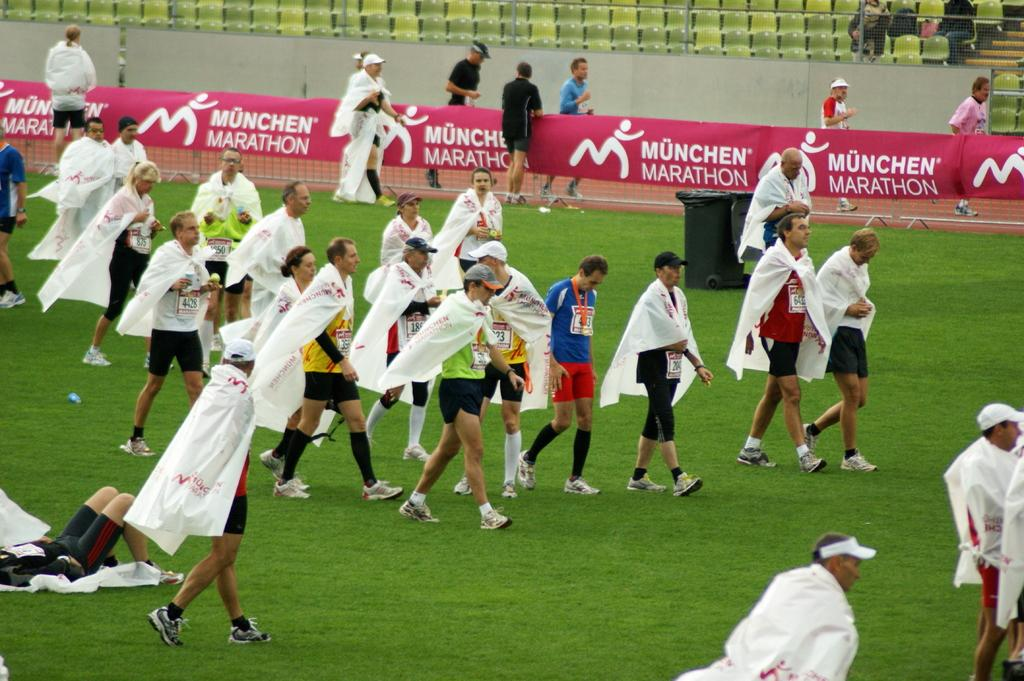<image>
Render a clear and concise summary of the photo. A group of people wearing shorts and white capes ona grassy field for the Munchen Marathon. 